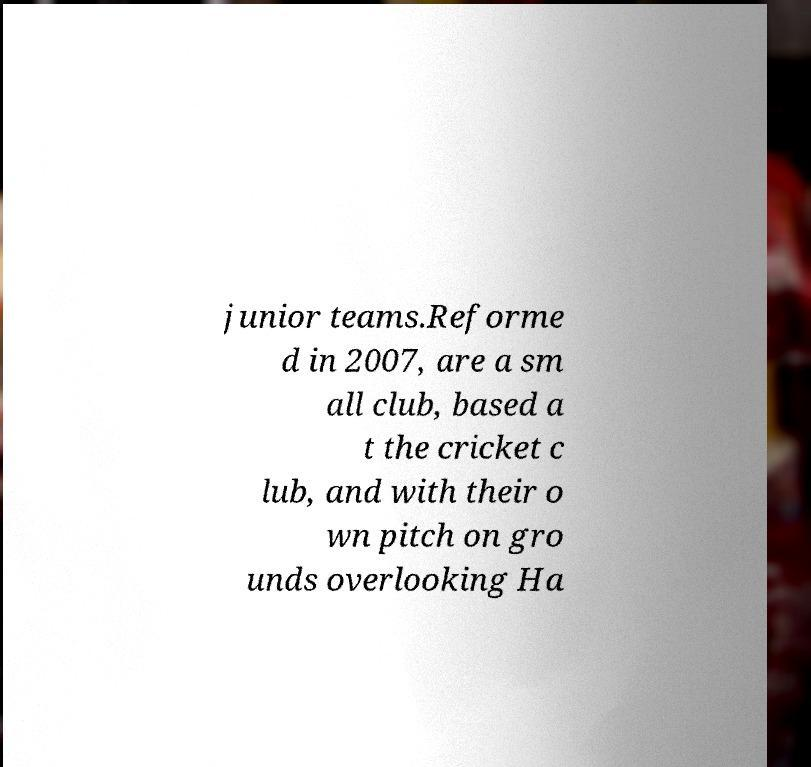Can you read and provide the text displayed in the image?This photo seems to have some interesting text. Can you extract and type it out for me? junior teams.Reforme d in 2007, are a sm all club, based a t the cricket c lub, and with their o wn pitch on gro unds overlooking Ha 